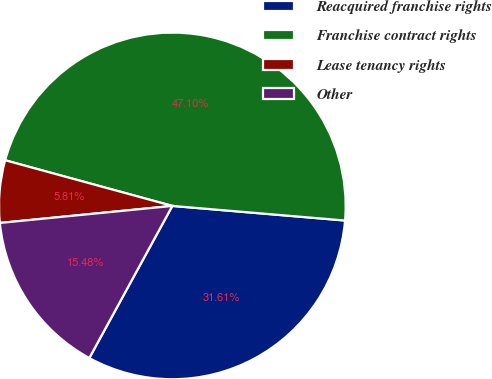<chart> <loc_0><loc_0><loc_500><loc_500><pie_chart><fcel>Reacquired franchise rights<fcel>Franchise contract rights<fcel>Lease tenancy rights<fcel>Other<nl><fcel>31.61%<fcel>47.1%<fcel>5.81%<fcel>15.48%<nl></chart> 